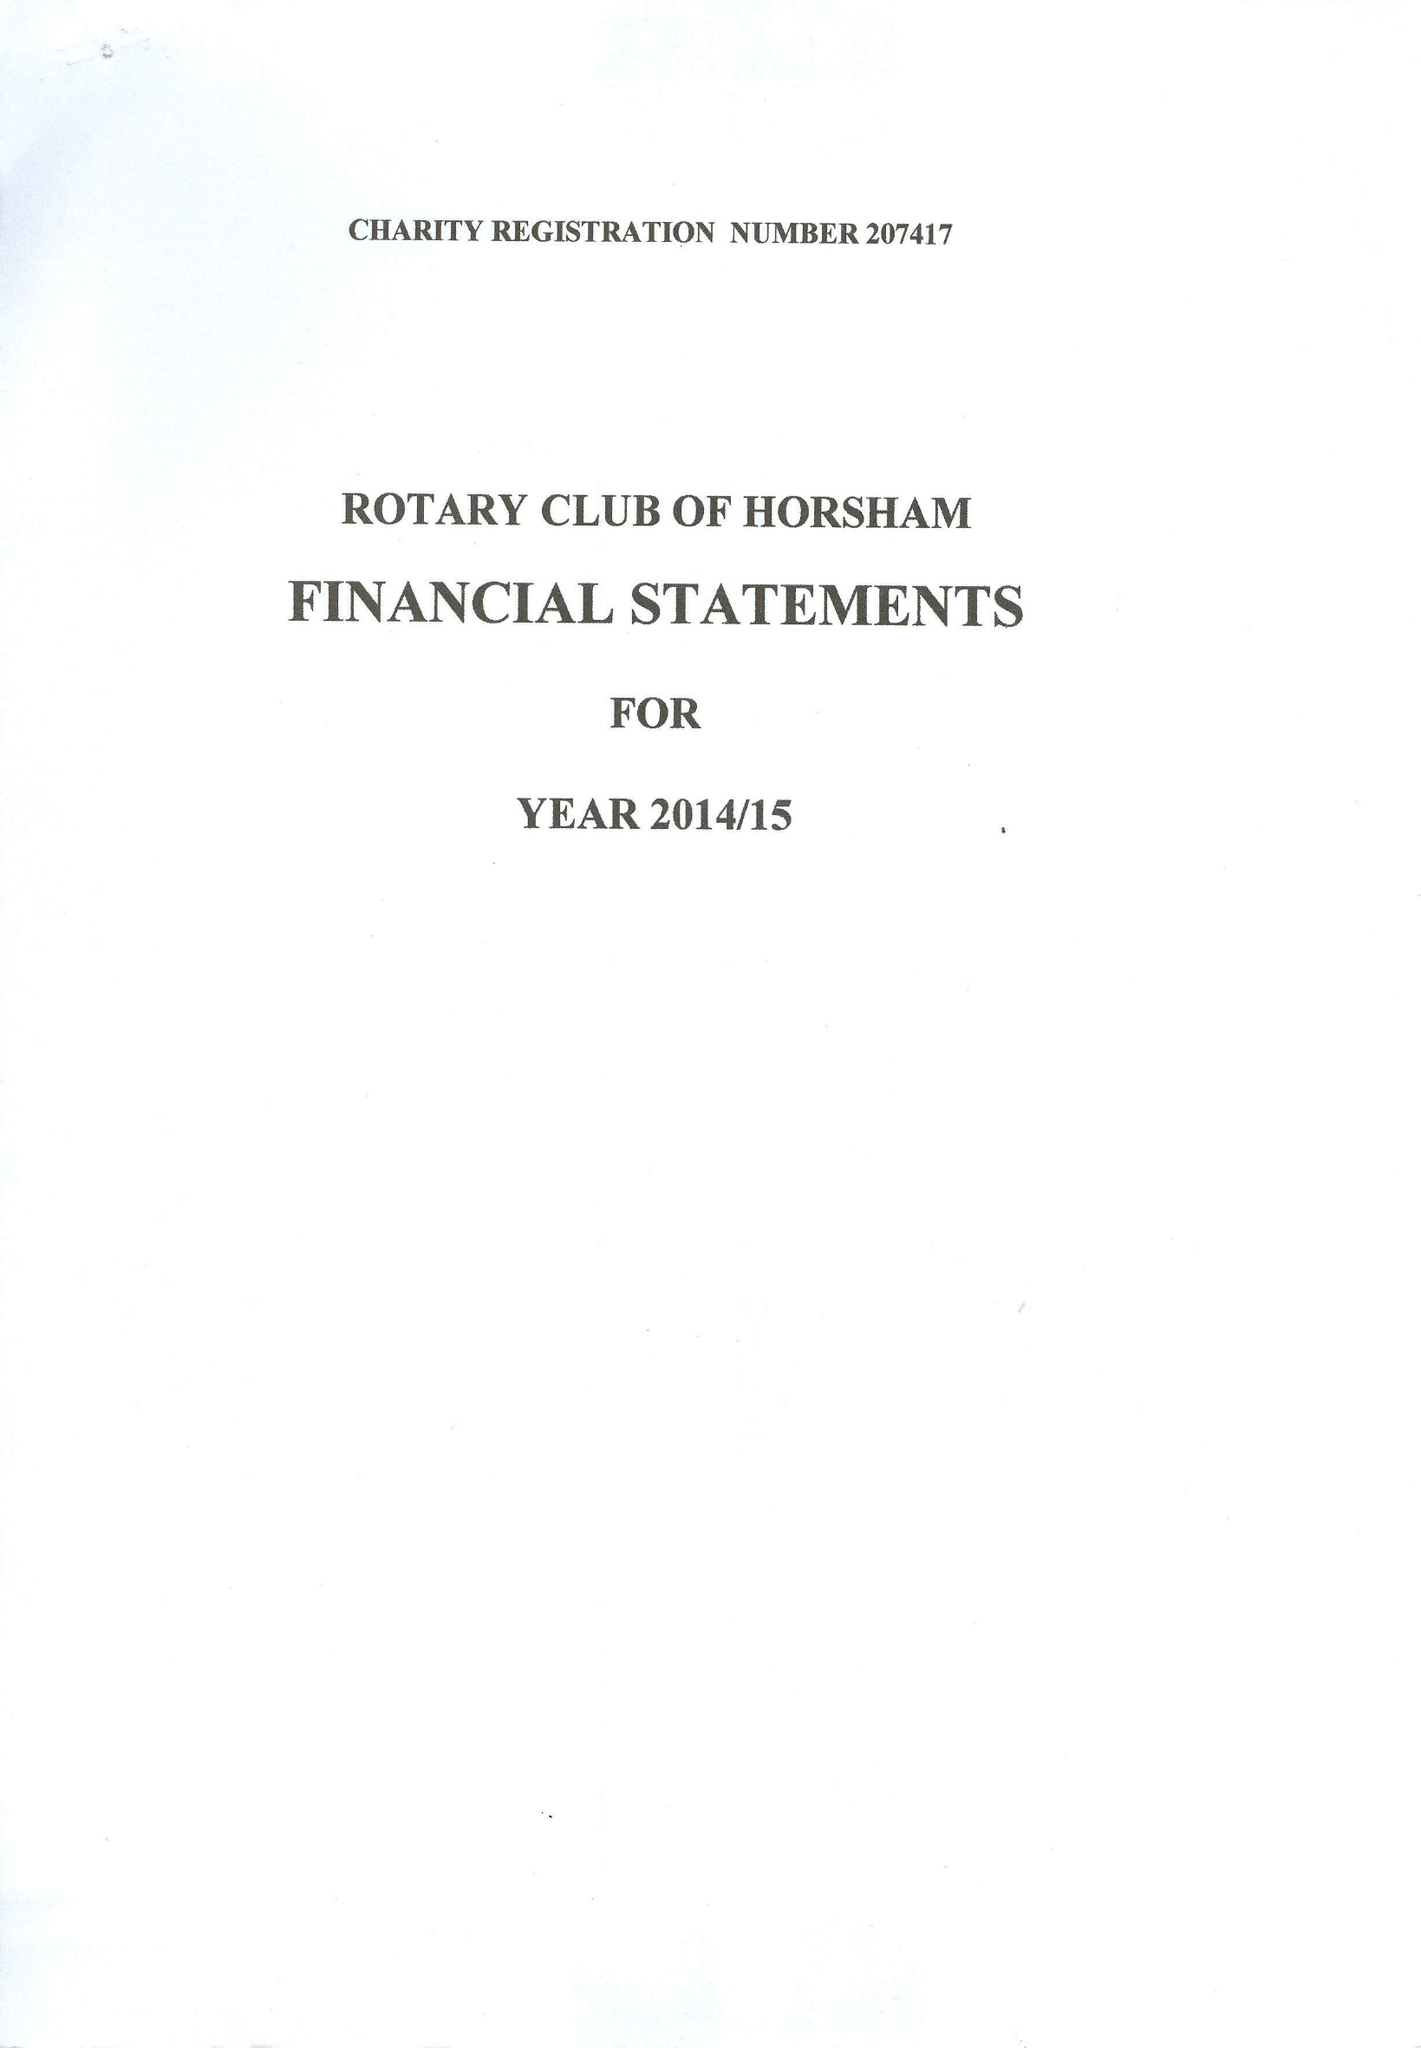What is the value for the report_date?
Answer the question using a single word or phrase. 2015-06-30 